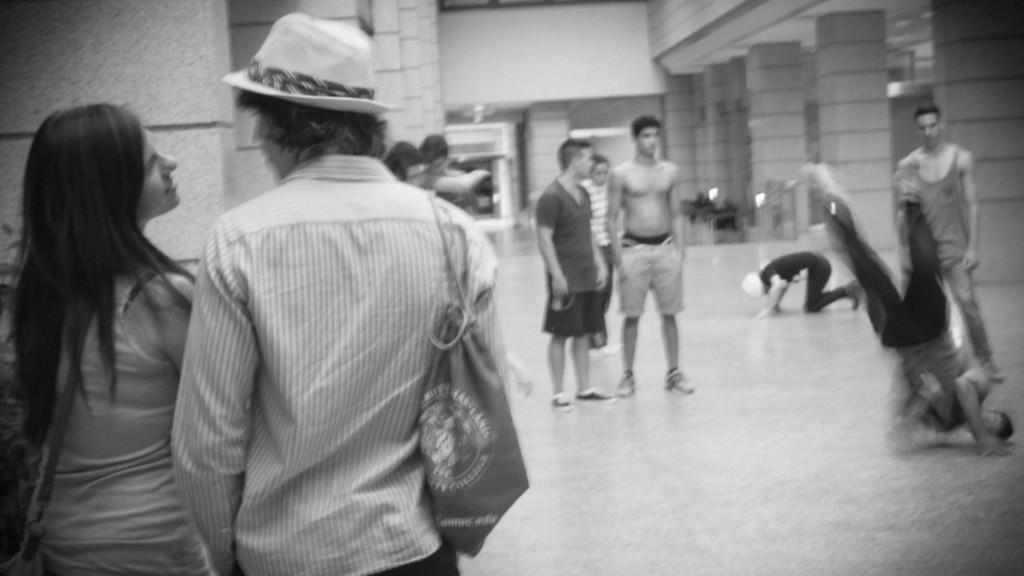In one or two sentences, can you explain what this image depicts? This is a black and white image. On the left side, I can see a man and a woman standing and looking at each other. The man is holding a bag. On the right side, I can see few people are standing on the floor and two persons are dancing. In the background, I can see few pillars and a building. 